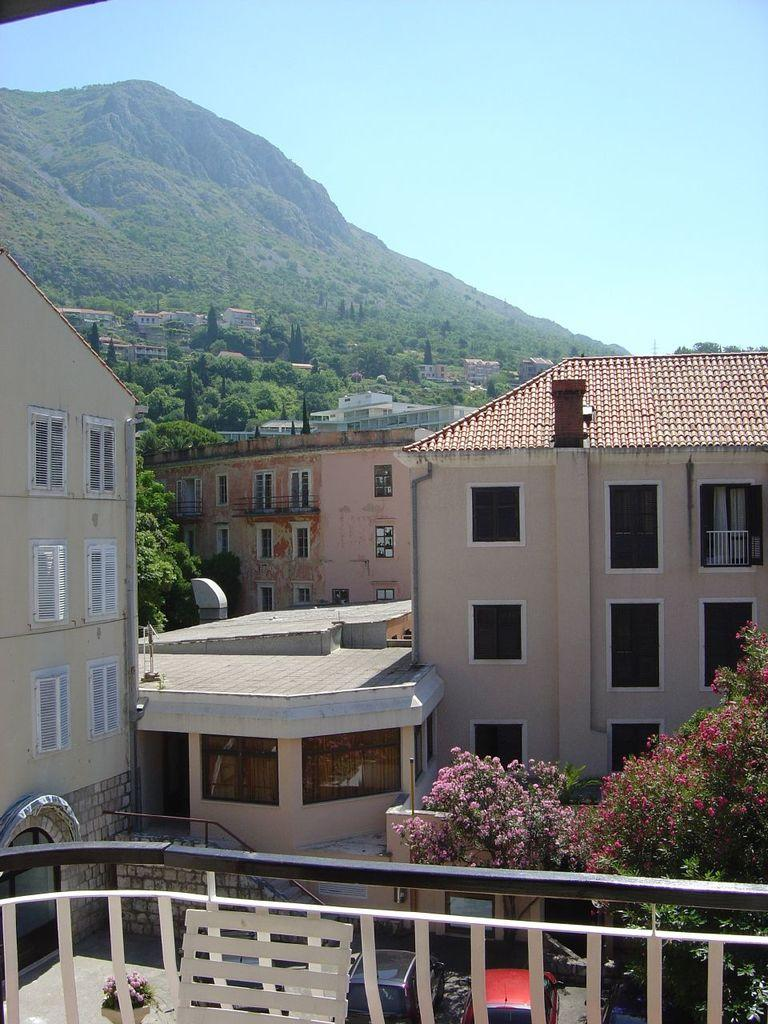What type of structures can be seen in the image? There are buildings in the image. What type of natural elements are present in the image? There are plants, flowers, and mountains in the image. What architectural features can be seen on the buildings? There is a grille and windows on the buildings in the image. What mode of transportation is visible in the image? There are vehicles in the image. What can be used for entering or exiting the buildings? There are doors in the image. What part of the natural environment is visible in the background of the image? The sky is visible in the background of the image. How long does it take for the guide to show the kite in the image? There is no guide or kite present in the image. How many minutes does it take for the plants to grow in the image? The image is a still photograph, so it does not show the passage of time or the growth of plants. 